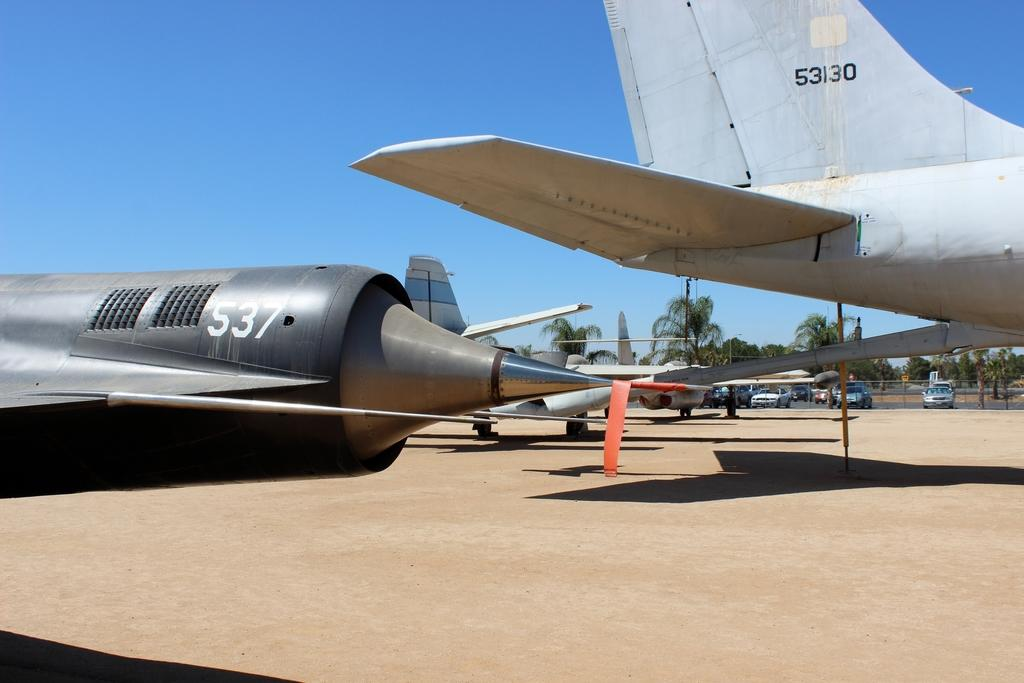<image>
Share a concise interpretation of the image provided. Airplanes sitting on the ground that are a silvery gray color and have 537 on one and 53130 on the other. 